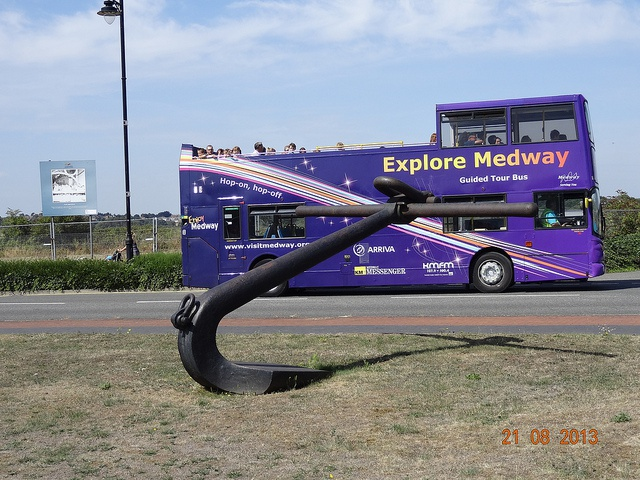Describe the objects in this image and their specific colors. I can see bus in lightblue, navy, darkblue, black, and purple tones, people in lightblue, black, gray, blue, and darkgray tones, people in lightblue, black, teal, and darkgreen tones, people in lightblue, gray, darkblue, and navy tones, and people in lightblue, lavender, black, and gray tones in this image. 